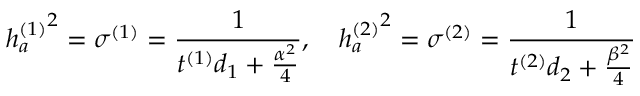<formula> <loc_0><loc_0><loc_500><loc_500>{ h _ { a } ^ { ( 1 ) } } ^ { 2 } = \sigma ^ { ( 1 ) } = { \frac { 1 } { t ^ { ( 1 ) } d _ { 1 } + { \frac { \alpha ^ { 2 } } { 4 } } } } , { h _ { a } ^ { ( 2 ) } } ^ { 2 } = \sigma ^ { ( 2 ) } = { \frac { 1 } { t ^ { ( 2 ) } d _ { 2 } + { \frac { \beta ^ { 2 } } { 4 } } } }</formula> 